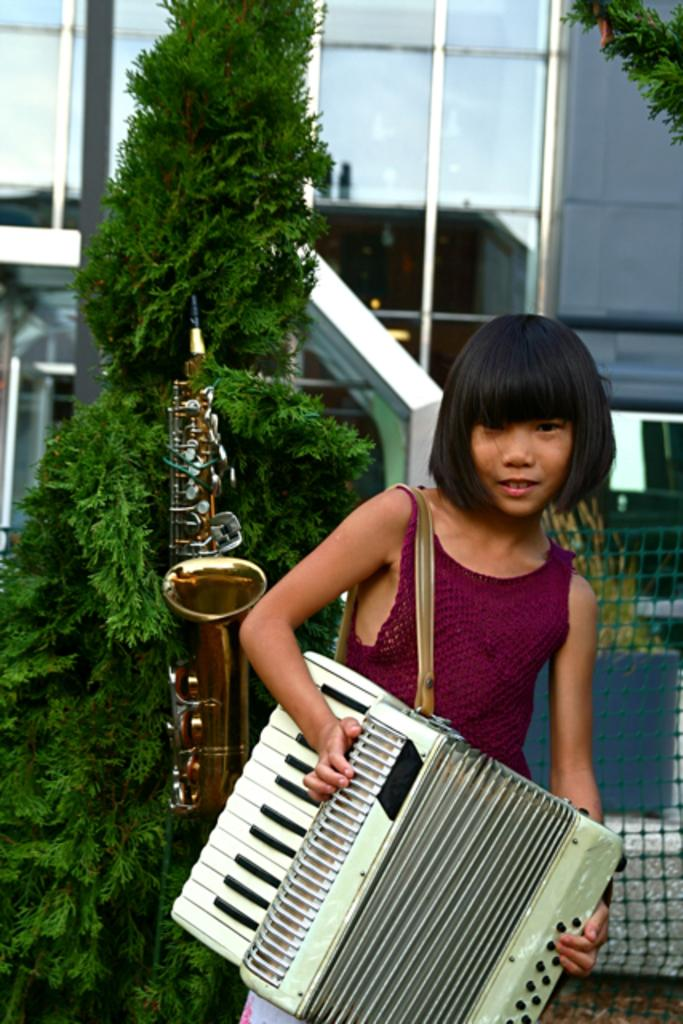Who is the main subject in the image? There is a girl in the image. What is the girl doing in the image? The girl is standing and smiling. What musical instrument is the girl holding in the image? The girl is holding an accordion. What other musical instrument can be seen in the image? There is a saxophone in the image. What type of vegetation is present in the image? There are plants in the image. What type of structure is visible in the image? There is a building in the image. What might be used for viewing or framing a scene in the image? The image has glasses, possibly referring to a window or a pair of glasses worn by someone in the image. What type of governor is visible in the image? There is no governor present in the image. What type of rake is being used to maintain the plants in the image? There is no rake present in the image; the plants are not being maintained in the image. 